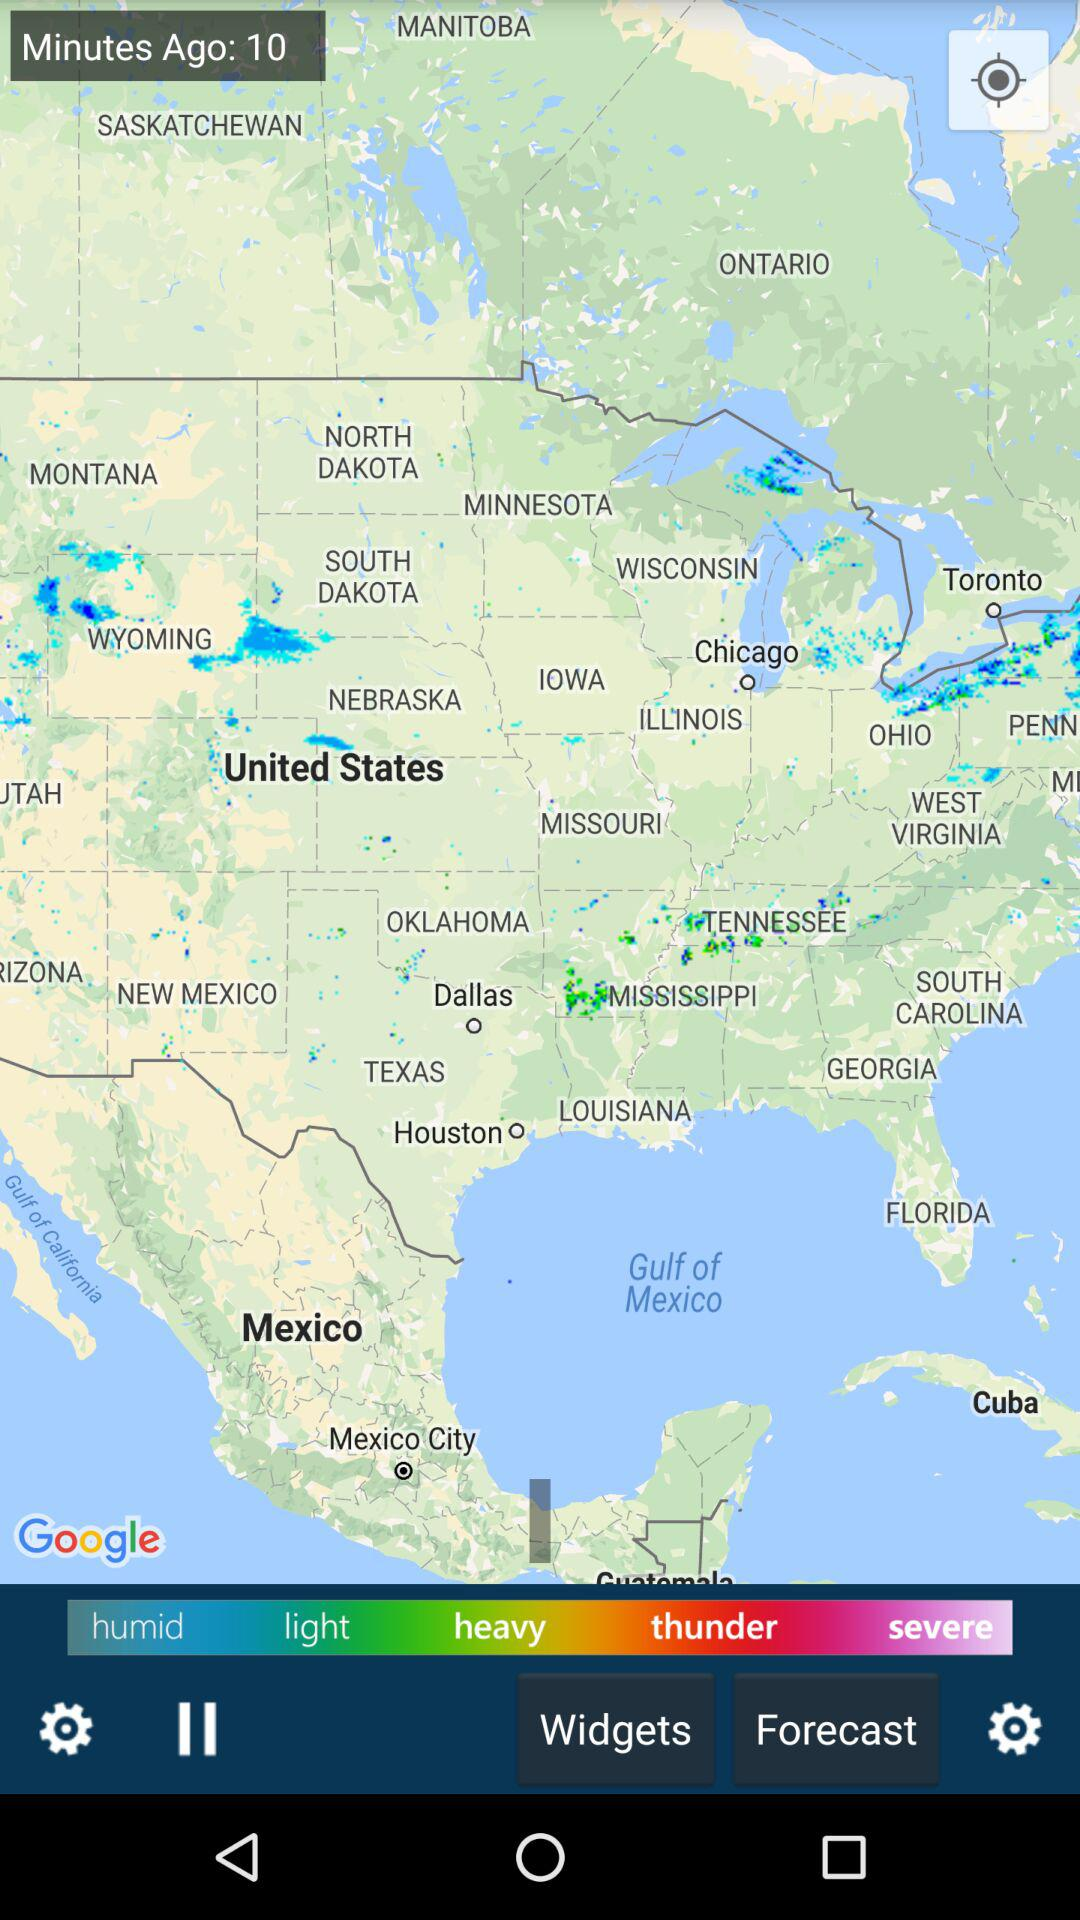How many minutes ago was the map updated? It was updated 10 minutes ago. 